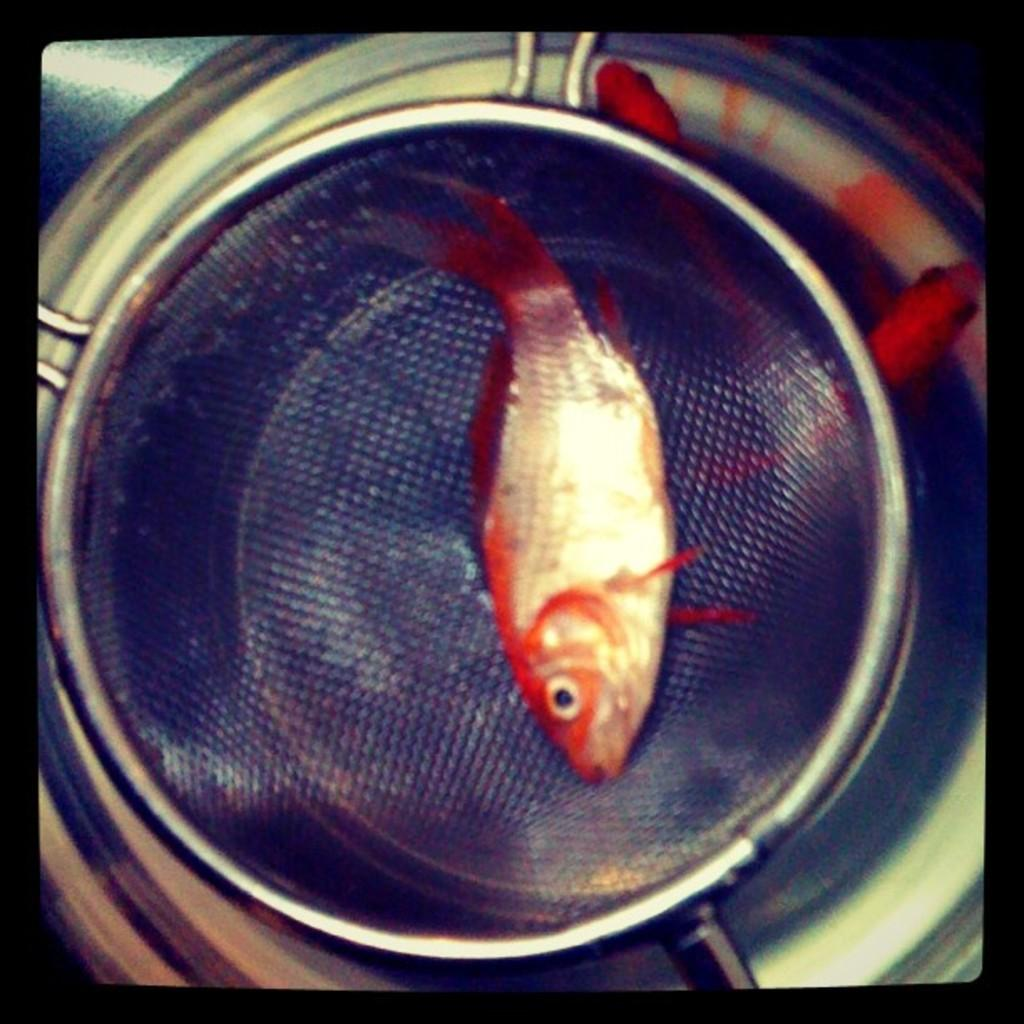What is located in the filter spoon in the image? There is a fish in a filter spoon in the image. What is positioned under the filter spoon? There is a bowl under the filter spoon. Where is the writer sitting in the image? There is no writer present in the image. What type of bird can be seen perched on the back of the fish? There is no bird, such as a robin, present in the image. 